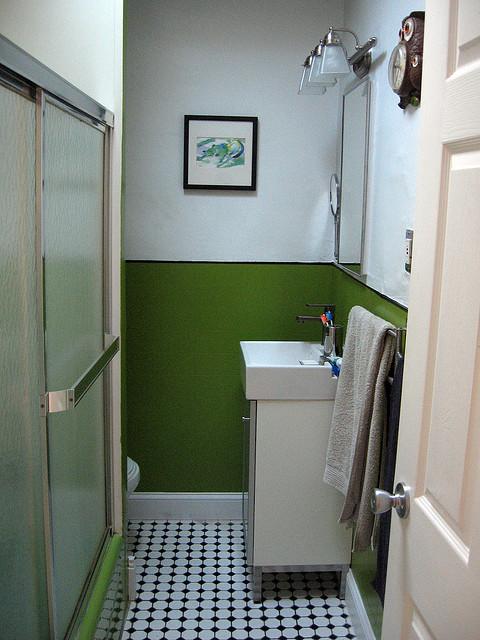What room is this?
Quick response, please. Bathroom. What color is the floor?
Give a very brief answer. Black and white. What type of room is this?
Answer briefly. Bathroom. 